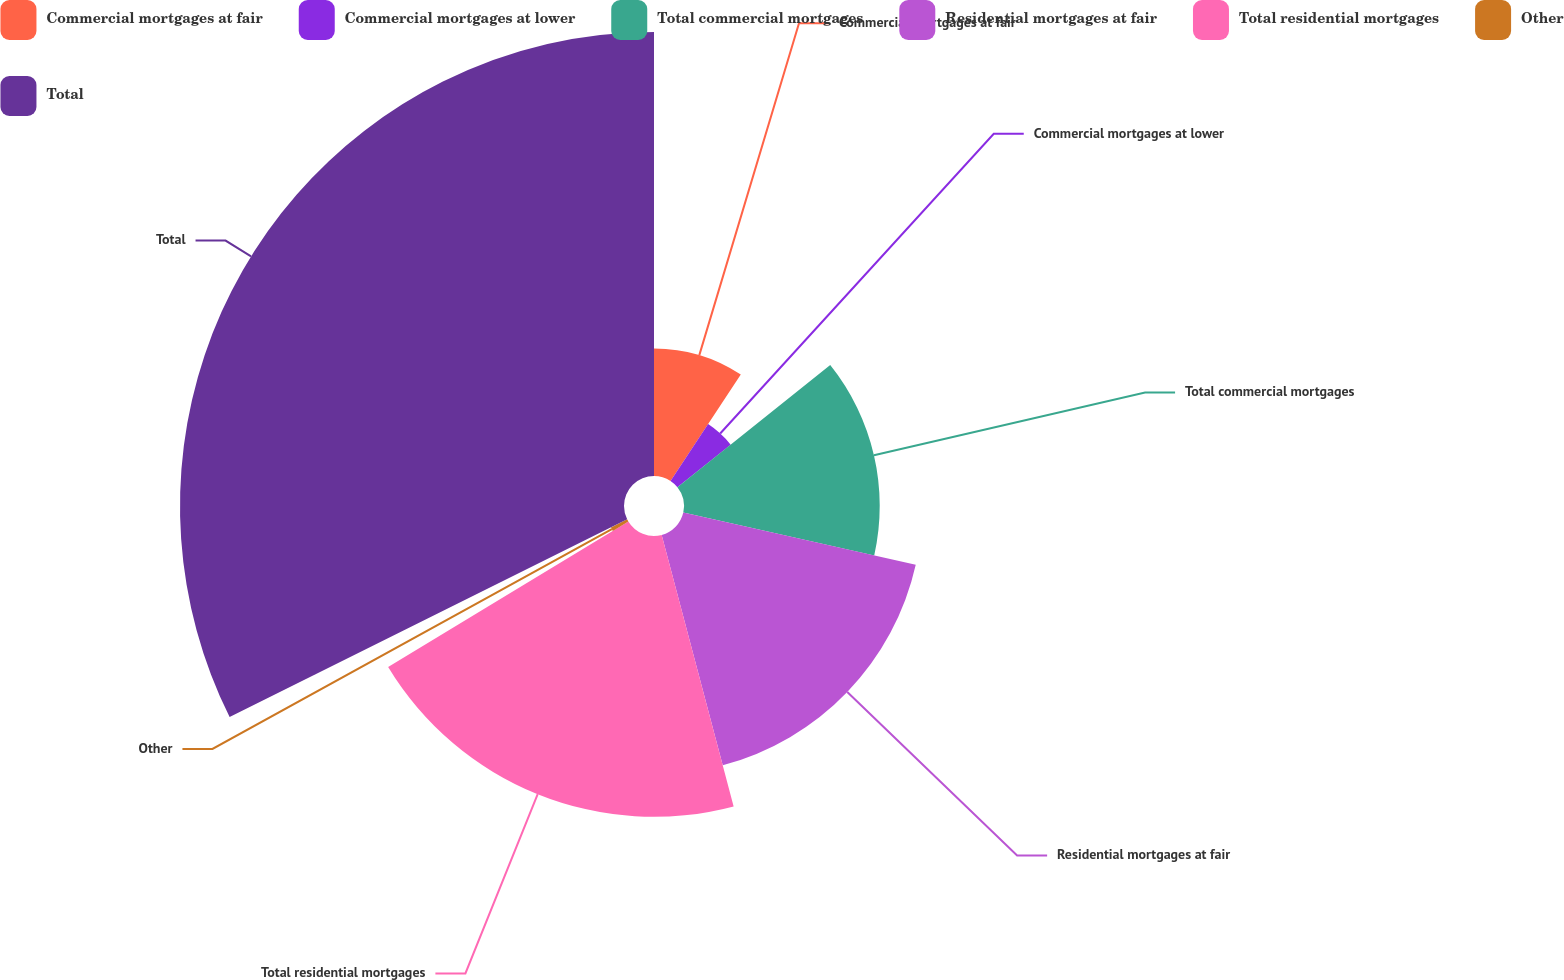Convert chart to OTSL. <chart><loc_0><loc_0><loc_500><loc_500><pie_chart><fcel>Commercial mortgages at fair<fcel>Commercial mortgages at lower<fcel>Total commercial mortgages<fcel>Residential mortgages at fair<fcel>Total residential mortgages<fcel>Other<fcel>Total<nl><fcel>9.29%<fcel>4.97%<fcel>14.26%<fcel>17.36%<fcel>20.46%<fcel>1.32%<fcel>32.35%<nl></chart> 